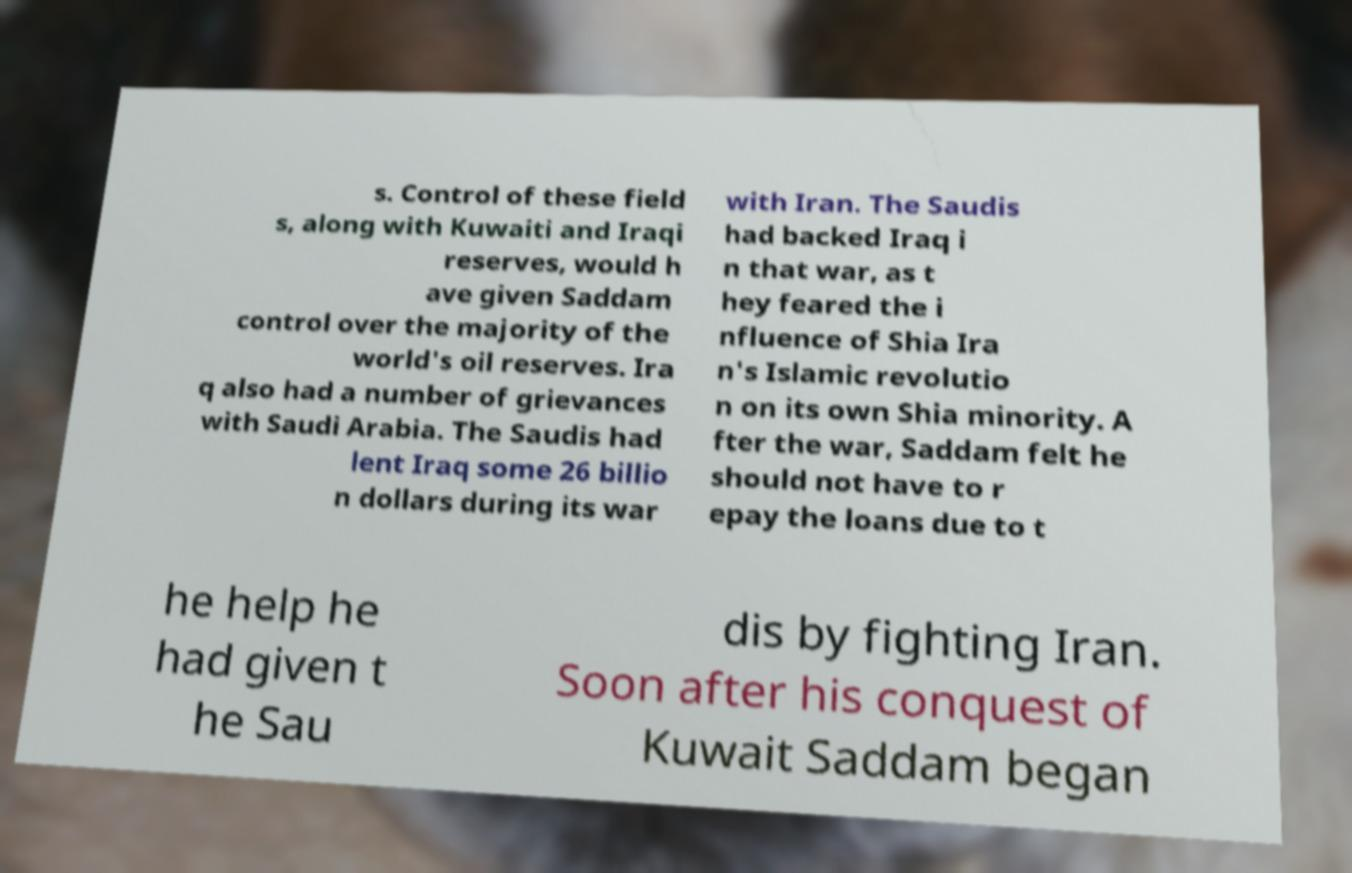I need the written content from this picture converted into text. Can you do that? s. Control of these field s, along with Kuwaiti and Iraqi reserves, would h ave given Saddam control over the majority of the world's oil reserves. Ira q also had a number of grievances with Saudi Arabia. The Saudis had lent Iraq some 26 billio n dollars during its war with Iran. The Saudis had backed Iraq i n that war, as t hey feared the i nfluence of Shia Ira n's Islamic revolutio n on its own Shia minority. A fter the war, Saddam felt he should not have to r epay the loans due to t he help he had given t he Sau dis by fighting Iran. Soon after his conquest of Kuwait Saddam began 